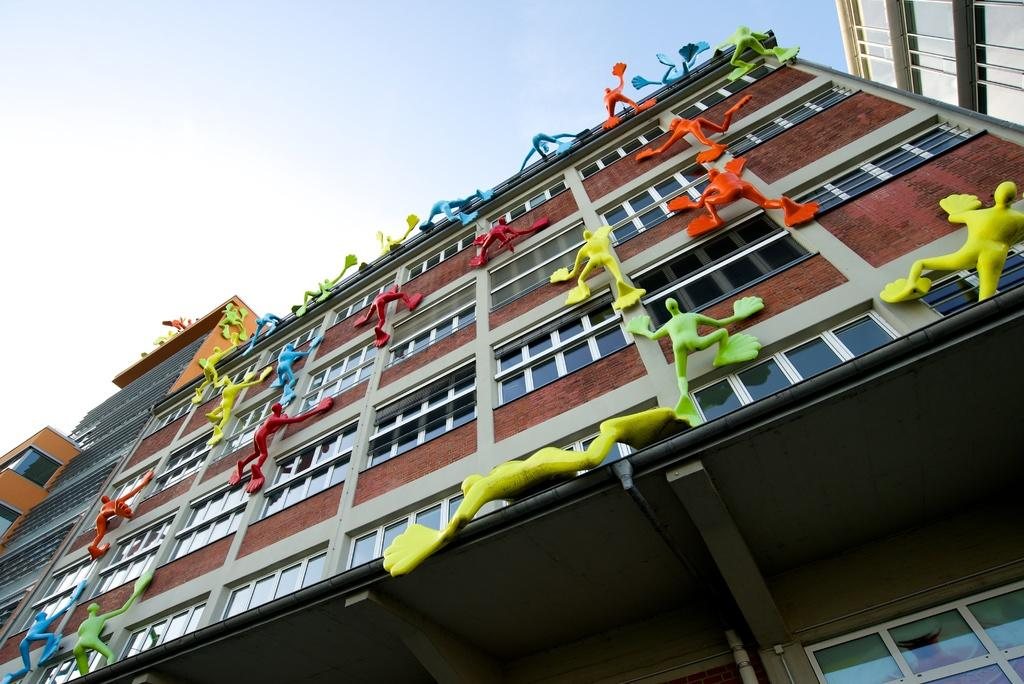What type of structures are present in the image? There are buildings with windows in the image. What decorative elements can be seen on the buildings? There are colorful sculptures on the buildings. What part of the natural environment is visible in the image? The sky is visible in the image. Where can the seat be found in the image? There is no seat present in the image. What type of jar is visible in the image? There is no jar present in the image. 